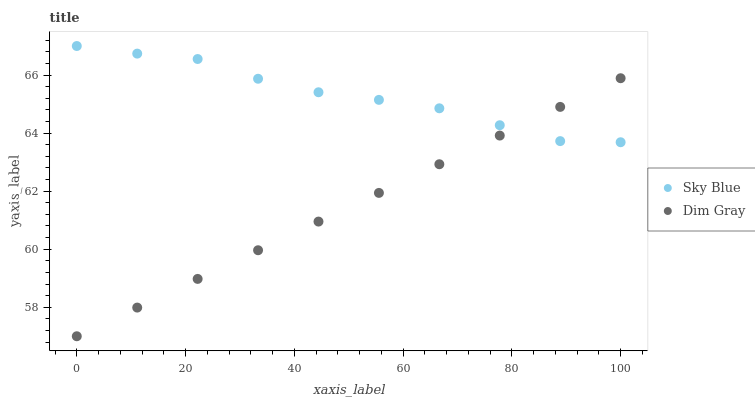Does Dim Gray have the minimum area under the curve?
Answer yes or no. Yes. Does Sky Blue have the maximum area under the curve?
Answer yes or no. Yes. Does Dim Gray have the maximum area under the curve?
Answer yes or no. No. Is Dim Gray the smoothest?
Answer yes or no. Yes. Is Sky Blue the roughest?
Answer yes or no. Yes. Is Dim Gray the roughest?
Answer yes or no. No. Does Dim Gray have the lowest value?
Answer yes or no. Yes. Does Sky Blue have the highest value?
Answer yes or no. Yes. Does Dim Gray have the highest value?
Answer yes or no. No. Does Dim Gray intersect Sky Blue?
Answer yes or no. Yes. Is Dim Gray less than Sky Blue?
Answer yes or no. No. Is Dim Gray greater than Sky Blue?
Answer yes or no. No. 